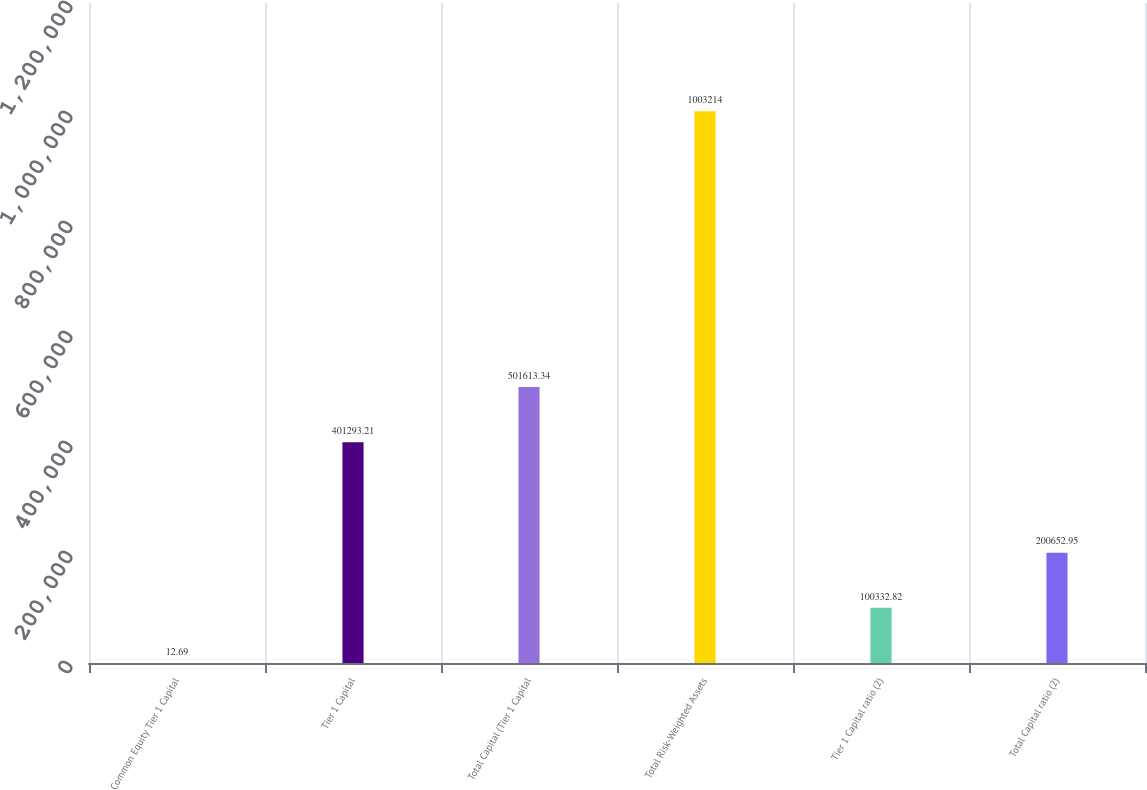Convert chart to OTSL. <chart><loc_0><loc_0><loc_500><loc_500><bar_chart><fcel>Common Equity Tier 1 Capital<fcel>Tier 1 Capital<fcel>Total Capital (Tier 1 Capital<fcel>Total Risk-Weighted Assets<fcel>Tier 1 Capital ratio (2)<fcel>Total Capital ratio (2)<nl><fcel>12.69<fcel>401293<fcel>501613<fcel>1.00321e+06<fcel>100333<fcel>200653<nl></chart> 